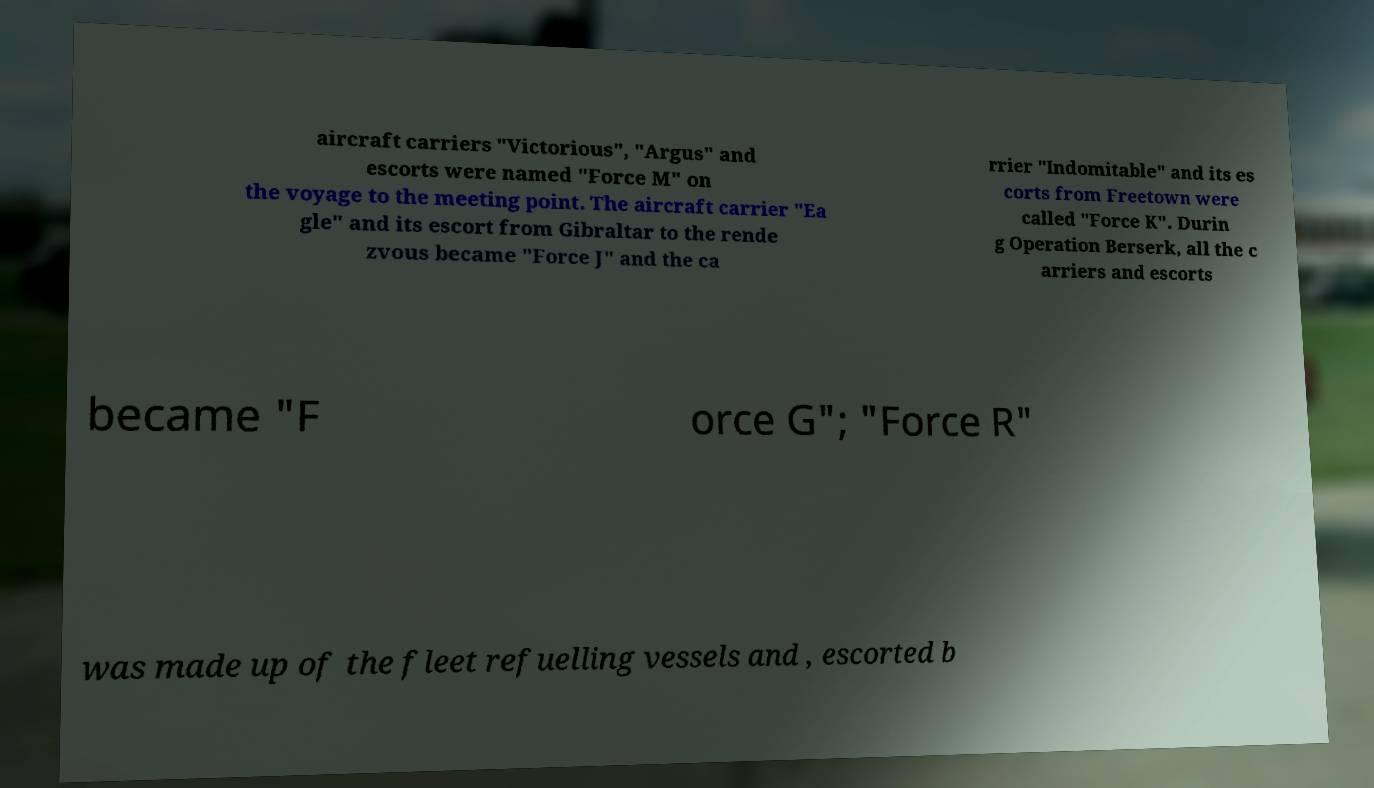Can you accurately transcribe the text from the provided image for me? aircraft carriers "Victorious", "Argus" and escorts were named "Force M" on the voyage to the meeting point. The aircraft carrier "Ea gle" and its escort from Gibraltar to the rende zvous became "Force J" and the ca rrier "Indomitable" and its es corts from Freetown were called "Force K". Durin g Operation Berserk, all the c arriers and escorts became "F orce G"; "Force R" was made up of the fleet refuelling vessels and , escorted b 